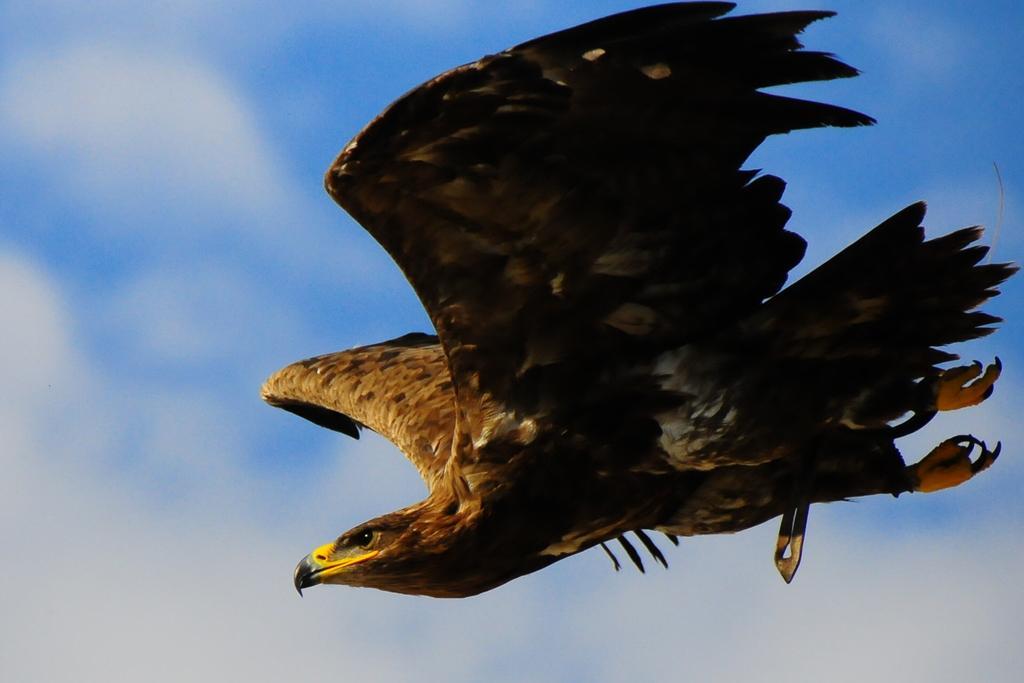Describe this image in one or two sentences. In the picture I can see an eagle is flying in the air. In the background I can see the sky. 